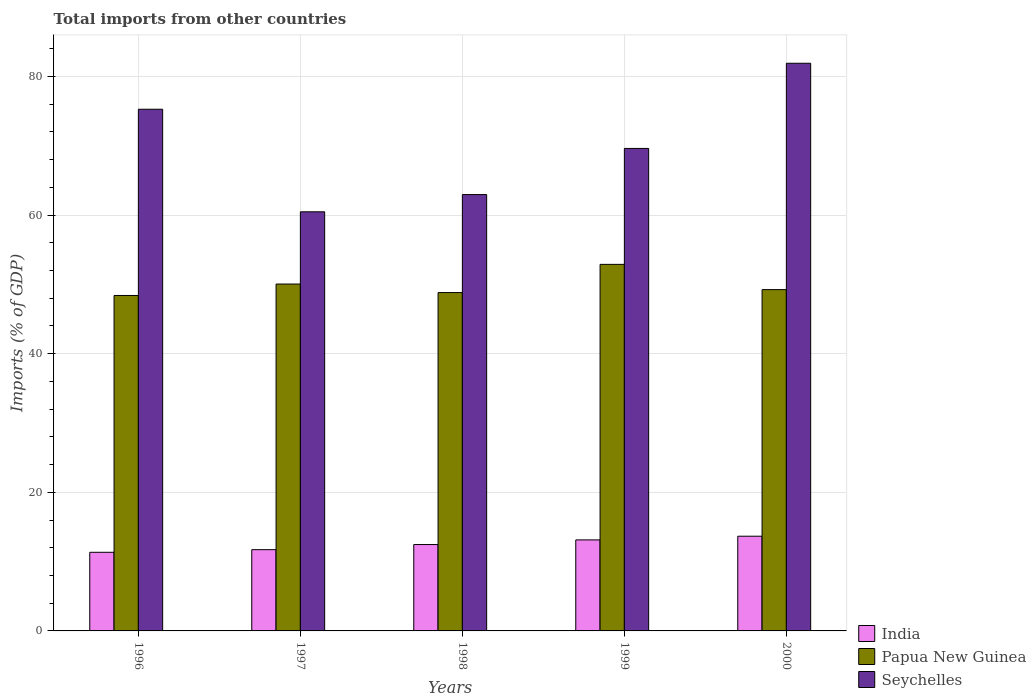How many different coloured bars are there?
Make the answer very short. 3. Are the number of bars per tick equal to the number of legend labels?
Offer a very short reply. Yes. Are the number of bars on each tick of the X-axis equal?
Offer a terse response. Yes. What is the label of the 2nd group of bars from the left?
Your answer should be very brief. 1997. In how many cases, is the number of bars for a given year not equal to the number of legend labels?
Make the answer very short. 0. What is the total imports in India in 2000?
Your answer should be compact. 13.66. Across all years, what is the maximum total imports in Seychelles?
Provide a succinct answer. 81.9. Across all years, what is the minimum total imports in Papua New Guinea?
Offer a very short reply. 48.4. In which year was the total imports in India maximum?
Make the answer very short. 2000. What is the total total imports in India in the graph?
Keep it short and to the point. 62.33. What is the difference between the total imports in Papua New Guinea in 1998 and that in 1999?
Provide a succinct answer. -4.07. What is the difference between the total imports in Seychelles in 2000 and the total imports in India in 1998?
Provide a succinct answer. 69.44. What is the average total imports in Seychelles per year?
Offer a very short reply. 70.04. In the year 1998, what is the difference between the total imports in India and total imports in Seychelles?
Your answer should be compact. -50.5. In how many years, is the total imports in India greater than 28 %?
Provide a succinct answer. 0. What is the ratio of the total imports in Papua New Guinea in 1998 to that in 1999?
Your answer should be very brief. 0.92. Is the total imports in Seychelles in 1996 less than that in 1998?
Give a very brief answer. No. What is the difference between the highest and the second highest total imports in Papua New Guinea?
Your response must be concise. 2.84. What is the difference between the highest and the lowest total imports in India?
Provide a succinct answer. 2.32. Is the sum of the total imports in India in 1997 and 2000 greater than the maximum total imports in Papua New Guinea across all years?
Provide a succinct answer. No. What does the 3rd bar from the left in 1999 represents?
Offer a very short reply. Seychelles. What does the 2nd bar from the right in 1998 represents?
Make the answer very short. Papua New Guinea. How many bars are there?
Your response must be concise. 15. Are all the bars in the graph horizontal?
Make the answer very short. No. Does the graph contain any zero values?
Provide a short and direct response. No. How many legend labels are there?
Provide a succinct answer. 3. How are the legend labels stacked?
Ensure brevity in your answer.  Vertical. What is the title of the graph?
Provide a short and direct response. Total imports from other countries. Does "Indonesia" appear as one of the legend labels in the graph?
Provide a succinct answer. No. What is the label or title of the Y-axis?
Offer a very short reply. Imports (% of GDP). What is the Imports (% of GDP) in India in 1996?
Your response must be concise. 11.35. What is the Imports (% of GDP) in Papua New Guinea in 1996?
Give a very brief answer. 48.4. What is the Imports (% of GDP) of Seychelles in 1996?
Your response must be concise. 75.27. What is the Imports (% of GDP) of India in 1997?
Offer a very short reply. 11.72. What is the Imports (% of GDP) in Papua New Guinea in 1997?
Ensure brevity in your answer.  50.05. What is the Imports (% of GDP) of Seychelles in 1997?
Ensure brevity in your answer.  60.47. What is the Imports (% of GDP) of India in 1998?
Your response must be concise. 12.46. What is the Imports (% of GDP) in Papua New Guinea in 1998?
Offer a very short reply. 48.82. What is the Imports (% of GDP) of Seychelles in 1998?
Offer a terse response. 62.96. What is the Imports (% of GDP) of India in 1999?
Provide a short and direct response. 13.13. What is the Imports (% of GDP) in Papua New Guinea in 1999?
Your answer should be very brief. 52.89. What is the Imports (% of GDP) in Seychelles in 1999?
Provide a succinct answer. 69.62. What is the Imports (% of GDP) in India in 2000?
Your response must be concise. 13.66. What is the Imports (% of GDP) of Papua New Guinea in 2000?
Your answer should be compact. 49.24. What is the Imports (% of GDP) of Seychelles in 2000?
Keep it short and to the point. 81.9. Across all years, what is the maximum Imports (% of GDP) of India?
Give a very brief answer. 13.66. Across all years, what is the maximum Imports (% of GDP) in Papua New Guinea?
Your answer should be very brief. 52.89. Across all years, what is the maximum Imports (% of GDP) of Seychelles?
Keep it short and to the point. 81.9. Across all years, what is the minimum Imports (% of GDP) of India?
Make the answer very short. 11.35. Across all years, what is the minimum Imports (% of GDP) of Papua New Guinea?
Your answer should be very brief. 48.4. Across all years, what is the minimum Imports (% of GDP) of Seychelles?
Provide a short and direct response. 60.47. What is the total Imports (% of GDP) of India in the graph?
Keep it short and to the point. 62.33. What is the total Imports (% of GDP) in Papua New Guinea in the graph?
Your answer should be compact. 249.4. What is the total Imports (% of GDP) of Seychelles in the graph?
Offer a very short reply. 350.22. What is the difference between the Imports (% of GDP) of India in 1996 and that in 1997?
Offer a very short reply. -0.38. What is the difference between the Imports (% of GDP) in Papua New Guinea in 1996 and that in 1997?
Keep it short and to the point. -1.65. What is the difference between the Imports (% of GDP) in Seychelles in 1996 and that in 1997?
Offer a very short reply. 14.8. What is the difference between the Imports (% of GDP) of India in 1996 and that in 1998?
Ensure brevity in your answer.  -1.12. What is the difference between the Imports (% of GDP) in Papua New Guinea in 1996 and that in 1998?
Your response must be concise. -0.42. What is the difference between the Imports (% of GDP) in Seychelles in 1996 and that in 1998?
Offer a very short reply. 12.31. What is the difference between the Imports (% of GDP) in India in 1996 and that in 1999?
Your response must be concise. -1.79. What is the difference between the Imports (% of GDP) of Papua New Guinea in 1996 and that in 1999?
Ensure brevity in your answer.  -4.49. What is the difference between the Imports (% of GDP) of Seychelles in 1996 and that in 1999?
Make the answer very short. 5.65. What is the difference between the Imports (% of GDP) of India in 1996 and that in 2000?
Your response must be concise. -2.32. What is the difference between the Imports (% of GDP) of Papua New Guinea in 1996 and that in 2000?
Provide a short and direct response. -0.84. What is the difference between the Imports (% of GDP) in Seychelles in 1996 and that in 2000?
Your answer should be very brief. -6.64. What is the difference between the Imports (% of GDP) in India in 1997 and that in 1998?
Ensure brevity in your answer.  -0.74. What is the difference between the Imports (% of GDP) in Papua New Guinea in 1997 and that in 1998?
Provide a short and direct response. 1.23. What is the difference between the Imports (% of GDP) of Seychelles in 1997 and that in 1998?
Keep it short and to the point. -2.49. What is the difference between the Imports (% of GDP) of India in 1997 and that in 1999?
Offer a terse response. -1.41. What is the difference between the Imports (% of GDP) of Papua New Guinea in 1997 and that in 1999?
Keep it short and to the point. -2.84. What is the difference between the Imports (% of GDP) in Seychelles in 1997 and that in 1999?
Offer a terse response. -9.14. What is the difference between the Imports (% of GDP) of India in 1997 and that in 2000?
Your response must be concise. -1.94. What is the difference between the Imports (% of GDP) in Papua New Guinea in 1997 and that in 2000?
Offer a terse response. 0.81. What is the difference between the Imports (% of GDP) of Seychelles in 1997 and that in 2000?
Ensure brevity in your answer.  -21.43. What is the difference between the Imports (% of GDP) in India in 1998 and that in 1999?
Ensure brevity in your answer.  -0.67. What is the difference between the Imports (% of GDP) of Papua New Guinea in 1998 and that in 1999?
Your response must be concise. -4.07. What is the difference between the Imports (% of GDP) of Seychelles in 1998 and that in 1999?
Provide a succinct answer. -6.66. What is the difference between the Imports (% of GDP) in India in 1998 and that in 2000?
Offer a terse response. -1.2. What is the difference between the Imports (% of GDP) in Papua New Guinea in 1998 and that in 2000?
Offer a terse response. -0.42. What is the difference between the Imports (% of GDP) of Seychelles in 1998 and that in 2000?
Your answer should be compact. -18.95. What is the difference between the Imports (% of GDP) in India in 1999 and that in 2000?
Ensure brevity in your answer.  -0.53. What is the difference between the Imports (% of GDP) of Papua New Guinea in 1999 and that in 2000?
Keep it short and to the point. 3.65. What is the difference between the Imports (% of GDP) in Seychelles in 1999 and that in 2000?
Your answer should be compact. -12.29. What is the difference between the Imports (% of GDP) in India in 1996 and the Imports (% of GDP) in Papua New Guinea in 1997?
Your answer should be very brief. -38.71. What is the difference between the Imports (% of GDP) of India in 1996 and the Imports (% of GDP) of Seychelles in 1997?
Ensure brevity in your answer.  -49.13. What is the difference between the Imports (% of GDP) of Papua New Guinea in 1996 and the Imports (% of GDP) of Seychelles in 1997?
Make the answer very short. -12.07. What is the difference between the Imports (% of GDP) in India in 1996 and the Imports (% of GDP) in Papua New Guinea in 1998?
Your response must be concise. -37.47. What is the difference between the Imports (% of GDP) of India in 1996 and the Imports (% of GDP) of Seychelles in 1998?
Provide a short and direct response. -51.61. What is the difference between the Imports (% of GDP) of Papua New Guinea in 1996 and the Imports (% of GDP) of Seychelles in 1998?
Your response must be concise. -14.56. What is the difference between the Imports (% of GDP) in India in 1996 and the Imports (% of GDP) in Papua New Guinea in 1999?
Give a very brief answer. -41.54. What is the difference between the Imports (% of GDP) in India in 1996 and the Imports (% of GDP) in Seychelles in 1999?
Make the answer very short. -58.27. What is the difference between the Imports (% of GDP) in Papua New Guinea in 1996 and the Imports (% of GDP) in Seychelles in 1999?
Offer a terse response. -21.22. What is the difference between the Imports (% of GDP) of India in 1996 and the Imports (% of GDP) of Papua New Guinea in 2000?
Offer a very short reply. -37.9. What is the difference between the Imports (% of GDP) of India in 1996 and the Imports (% of GDP) of Seychelles in 2000?
Keep it short and to the point. -70.56. What is the difference between the Imports (% of GDP) of Papua New Guinea in 1996 and the Imports (% of GDP) of Seychelles in 2000?
Your answer should be compact. -33.51. What is the difference between the Imports (% of GDP) in India in 1997 and the Imports (% of GDP) in Papua New Guinea in 1998?
Offer a very short reply. -37.1. What is the difference between the Imports (% of GDP) of India in 1997 and the Imports (% of GDP) of Seychelles in 1998?
Provide a short and direct response. -51.24. What is the difference between the Imports (% of GDP) of Papua New Guinea in 1997 and the Imports (% of GDP) of Seychelles in 1998?
Make the answer very short. -12.91. What is the difference between the Imports (% of GDP) in India in 1997 and the Imports (% of GDP) in Papua New Guinea in 1999?
Make the answer very short. -41.17. What is the difference between the Imports (% of GDP) in India in 1997 and the Imports (% of GDP) in Seychelles in 1999?
Provide a short and direct response. -57.89. What is the difference between the Imports (% of GDP) of Papua New Guinea in 1997 and the Imports (% of GDP) of Seychelles in 1999?
Offer a terse response. -19.57. What is the difference between the Imports (% of GDP) of India in 1997 and the Imports (% of GDP) of Papua New Guinea in 2000?
Your response must be concise. -37.52. What is the difference between the Imports (% of GDP) in India in 1997 and the Imports (% of GDP) in Seychelles in 2000?
Offer a terse response. -70.18. What is the difference between the Imports (% of GDP) in Papua New Guinea in 1997 and the Imports (% of GDP) in Seychelles in 2000?
Make the answer very short. -31.85. What is the difference between the Imports (% of GDP) in India in 1998 and the Imports (% of GDP) in Papua New Guinea in 1999?
Your answer should be compact. -40.43. What is the difference between the Imports (% of GDP) in India in 1998 and the Imports (% of GDP) in Seychelles in 1999?
Offer a terse response. -57.15. What is the difference between the Imports (% of GDP) of Papua New Guinea in 1998 and the Imports (% of GDP) of Seychelles in 1999?
Provide a short and direct response. -20.8. What is the difference between the Imports (% of GDP) in India in 1998 and the Imports (% of GDP) in Papua New Guinea in 2000?
Give a very brief answer. -36.78. What is the difference between the Imports (% of GDP) of India in 1998 and the Imports (% of GDP) of Seychelles in 2000?
Your answer should be compact. -69.44. What is the difference between the Imports (% of GDP) in Papua New Guinea in 1998 and the Imports (% of GDP) in Seychelles in 2000?
Offer a very short reply. -33.09. What is the difference between the Imports (% of GDP) in India in 1999 and the Imports (% of GDP) in Papua New Guinea in 2000?
Ensure brevity in your answer.  -36.11. What is the difference between the Imports (% of GDP) of India in 1999 and the Imports (% of GDP) of Seychelles in 2000?
Your answer should be compact. -68.77. What is the difference between the Imports (% of GDP) of Papua New Guinea in 1999 and the Imports (% of GDP) of Seychelles in 2000?
Keep it short and to the point. -29.02. What is the average Imports (% of GDP) in India per year?
Your response must be concise. 12.47. What is the average Imports (% of GDP) of Papua New Guinea per year?
Provide a short and direct response. 49.88. What is the average Imports (% of GDP) in Seychelles per year?
Offer a terse response. 70.04. In the year 1996, what is the difference between the Imports (% of GDP) of India and Imports (% of GDP) of Papua New Guinea?
Your answer should be compact. -37.05. In the year 1996, what is the difference between the Imports (% of GDP) in India and Imports (% of GDP) in Seychelles?
Your answer should be very brief. -63.92. In the year 1996, what is the difference between the Imports (% of GDP) in Papua New Guinea and Imports (% of GDP) in Seychelles?
Your answer should be compact. -26.87. In the year 1997, what is the difference between the Imports (% of GDP) in India and Imports (% of GDP) in Papua New Guinea?
Your response must be concise. -38.33. In the year 1997, what is the difference between the Imports (% of GDP) in India and Imports (% of GDP) in Seychelles?
Offer a terse response. -48.75. In the year 1997, what is the difference between the Imports (% of GDP) of Papua New Guinea and Imports (% of GDP) of Seychelles?
Provide a short and direct response. -10.42. In the year 1998, what is the difference between the Imports (% of GDP) of India and Imports (% of GDP) of Papua New Guinea?
Keep it short and to the point. -36.36. In the year 1998, what is the difference between the Imports (% of GDP) of India and Imports (% of GDP) of Seychelles?
Your answer should be very brief. -50.5. In the year 1998, what is the difference between the Imports (% of GDP) of Papua New Guinea and Imports (% of GDP) of Seychelles?
Provide a succinct answer. -14.14. In the year 1999, what is the difference between the Imports (% of GDP) of India and Imports (% of GDP) of Papua New Guinea?
Offer a very short reply. -39.76. In the year 1999, what is the difference between the Imports (% of GDP) of India and Imports (% of GDP) of Seychelles?
Your response must be concise. -56.48. In the year 1999, what is the difference between the Imports (% of GDP) in Papua New Guinea and Imports (% of GDP) in Seychelles?
Your response must be concise. -16.73. In the year 2000, what is the difference between the Imports (% of GDP) in India and Imports (% of GDP) in Papua New Guinea?
Give a very brief answer. -35.58. In the year 2000, what is the difference between the Imports (% of GDP) in India and Imports (% of GDP) in Seychelles?
Provide a short and direct response. -68.24. In the year 2000, what is the difference between the Imports (% of GDP) in Papua New Guinea and Imports (% of GDP) in Seychelles?
Keep it short and to the point. -32.66. What is the ratio of the Imports (% of GDP) of India in 1996 to that in 1997?
Make the answer very short. 0.97. What is the ratio of the Imports (% of GDP) of Papua New Guinea in 1996 to that in 1997?
Your answer should be compact. 0.97. What is the ratio of the Imports (% of GDP) in Seychelles in 1996 to that in 1997?
Offer a terse response. 1.24. What is the ratio of the Imports (% of GDP) in India in 1996 to that in 1998?
Provide a short and direct response. 0.91. What is the ratio of the Imports (% of GDP) of Papua New Guinea in 1996 to that in 1998?
Give a very brief answer. 0.99. What is the ratio of the Imports (% of GDP) in Seychelles in 1996 to that in 1998?
Your response must be concise. 1.2. What is the ratio of the Imports (% of GDP) of India in 1996 to that in 1999?
Your response must be concise. 0.86. What is the ratio of the Imports (% of GDP) of Papua New Guinea in 1996 to that in 1999?
Your answer should be compact. 0.92. What is the ratio of the Imports (% of GDP) in Seychelles in 1996 to that in 1999?
Provide a succinct answer. 1.08. What is the ratio of the Imports (% of GDP) of India in 1996 to that in 2000?
Provide a short and direct response. 0.83. What is the ratio of the Imports (% of GDP) of Papua New Guinea in 1996 to that in 2000?
Offer a terse response. 0.98. What is the ratio of the Imports (% of GDP) of Seychelles in 1996 to that in 2000?
Provide a short and direct response. 0.92. What is the ratio of the Imports (% of GDP) of India in 1997 to that in 1998?
Provide a short and direct response. 0.94. What is the ratio of the Imports (% of GDP) in Papua New Guinea in 1997 to that in 1998?
Offer a very short reply. 1.03. What is the ratio of the Imports (% of GDP) of Seychelles in 1997 to that in 1998?
Offer a very short reply. 0.96. What is the ratio of the Imports (% of GDP) of India in 1997 to that in 1999?
Ensure brevity in your answer.  0.89. What is the ratio of the Imports (% of GDP) of Papua New Guinea in 1997 to that in 1999?
Make the answer very short. 0.95. What is the ratio of the Imports (% of GDP) in Seychelles in 1997 to that in 1999?
Your answer should be compact. 0.87. What is the ratio of the Imports (% of GDP) in India in 1997 to that in 2000?
Provide a short and direct response. 0.86. What is the ratio of the Imports (% of GDP) in Papua New Guinea in 1997 to that in 2000?
Your response must be concise. 1.02. What is the ratio of the Imports (% of GDP) in Seychelles in 1997 to that in 2000?
Make the answer very short. 0.74. What is the ratio of the Imports (% of GDP) in India in 1998 to that in 1999?
Give a very brief answer. 0.95. What is the ratio of the Imports (% of GDP) in Seychelles in 1998 to that in 1999?
Provide a succinct answer. 0.9. What is the ratio of the Imports (% of GDP) of India in 1998 to that in 2000?
Ensure brevity in your answer.  0.91. What is the ratio of the Imports (% of GDP) of Papua New Guinea in 1998 to that in 2000?
Your answer should be very brief. 0.99. What is the ratio of the Imports (% of GDP) in Seychelles in 1998 to that in 2000?
Give a very brief answer. 0.77. What is the ratio of the Imports (% of GDP) of India in 1999 to that in 2000?
Your response must be concise. 0.96. What is the ratio of the Imports (% of GDP) in Papua New Guinea in 1999 to that in 2000?
Keep it short and to the point. 1.07. What is the difference between the highest and the second highest Imports (% of GDP) in India?
Give a very brief answer. 0.53. What is the difference between the highest and the second highest Imports (% of GDP) in Papua New Guinea?
Provide a short and direct response. 2.84. What is the difference between the highest and the second highest Imports (% of GDP) of Seychelles?
Ensure brevity in your answer.  6.64. What is the difference between the highest and the lowest Imports (% of GDP) of India?
Ensure brevity in your answer.  2.32. What is the difference between the highest and the lowest Imports (% of GDP) of Papua New Guinea?
Give a very brief answer. 4.49. What is the difference between the highest and the lowest Imports (% of GDP) of Seychelles?
Your answer should be very brief. 21.43. 